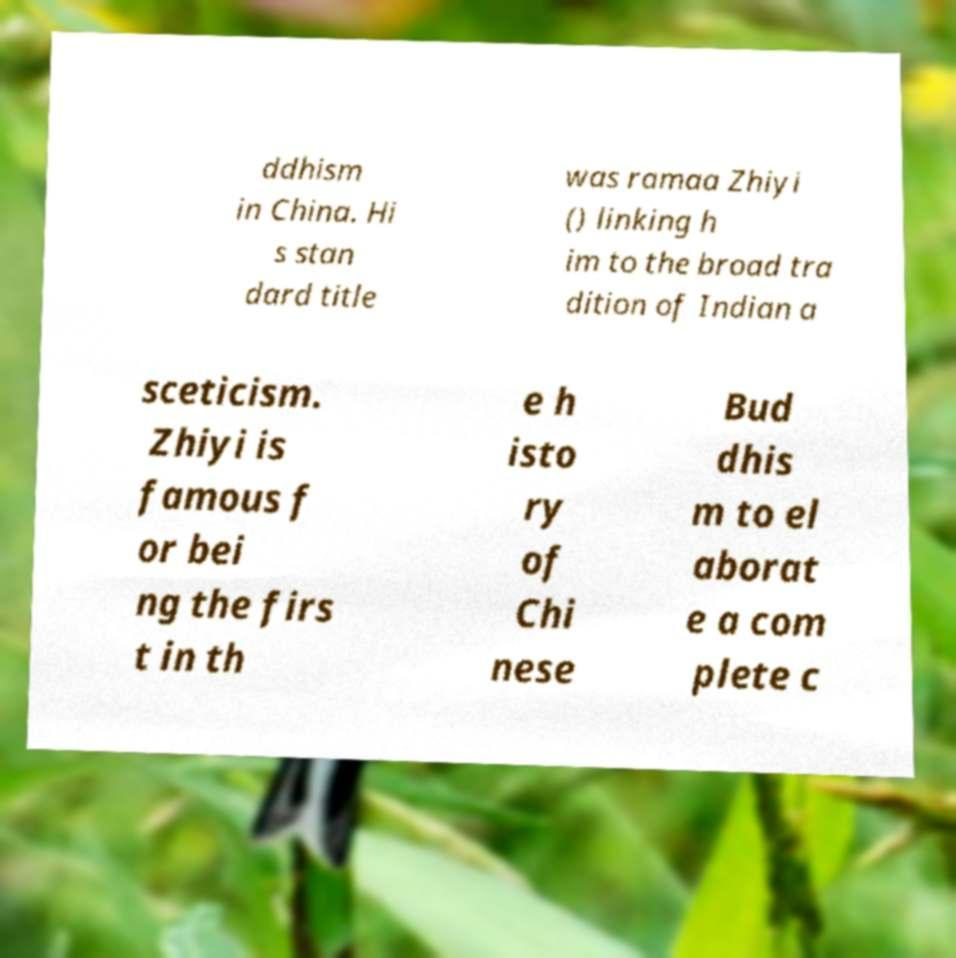What messages or text are displayed in this image? I need them in a readable, typed format. ddhism in China. Hi s stan dard title was ramaa Zhiyi () linking h im to the broad tra dition of Indian a sceticism. Zhiyi is famous f or bei ng the firs t in th e h isto ry of Chi nese Bud dhis m to el aborat e a com plete c 